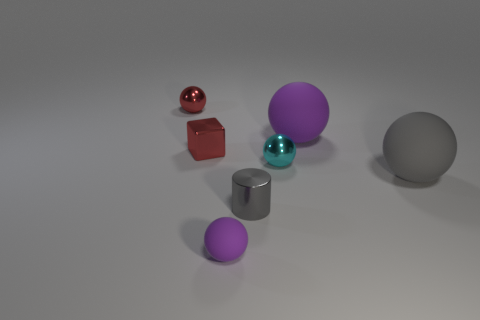Is there any other thing that has the same shape as the small gray object?
Make the answer very short. No. There is a shiny thing in front of the big object right of the big purple ball; what size is it?
Provide a short and direct response. Small. Does the tiny metallic cylinder have the same color as the big sphere that is on the right side of the big purple thing?
Your answer should be compact. Yes. How many other objects are there of the same material as the small purple sphere?
Make the answer very short. 2. What is the shape of the cyan thing that is the same material as the tiny red sphere?
Provide a short and direct response. Sphere. Are there any other things that have the same color as the metallic cube?
Provide a short and direct response. Yes. What size is the ball that is the same color as the shiny cylinder?
Provide a short and direct response. Large. Are there more large balls behind the small cyan metallic object than big green metal blocks?
Your response must be concise. Yes. There is a small cyan object; is it the same shape as the metal thing that is in front of the cyan object?
Provide a succinct answer. No. How many gray objects are the same size as the metal cylinder?
Ensure brevity in your answer.  0. 